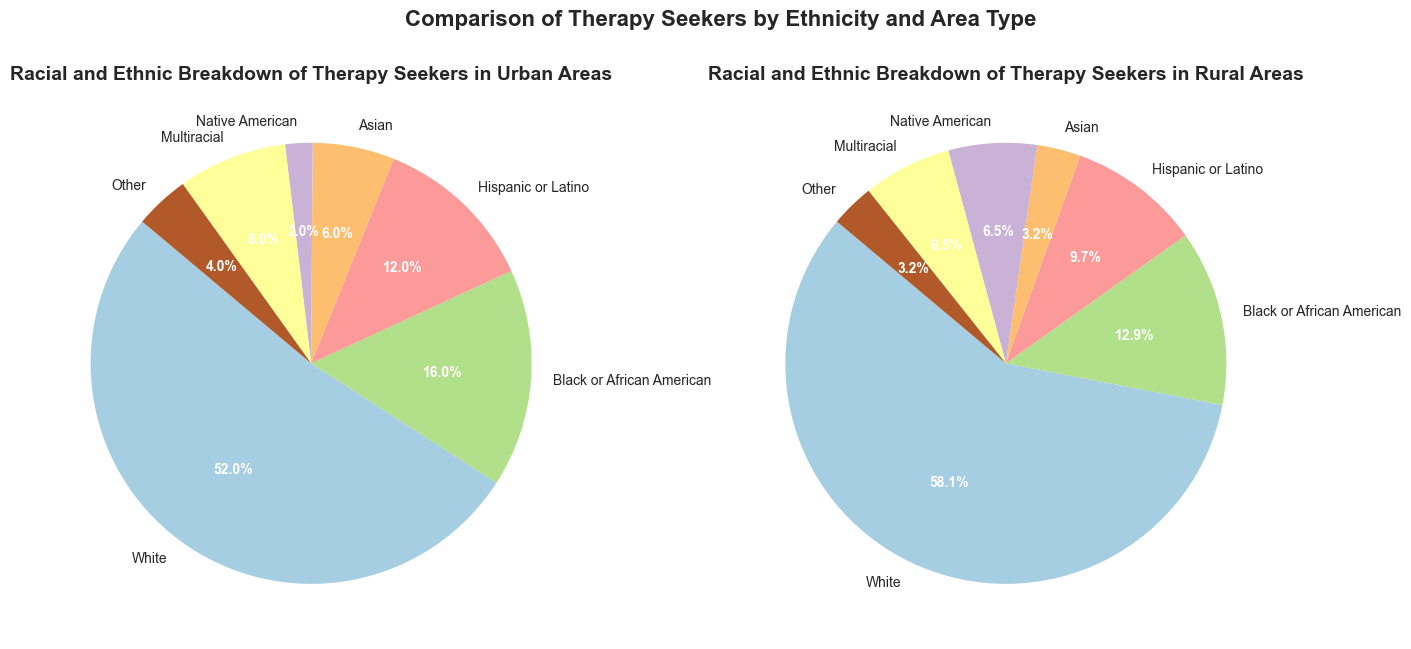Which ethnicity has the highest percentage of therapy seekers in both urban and rural areas? In the urban pie chart, the 'White' segment is the largest, representing 52%. In the rural pie chart, the 'White' segment is also the largest at 60%. Therefore, White has the highest percentage in both areas.
Answer: White Which ethnic group shows the largest difference in therapy seeker percentage between urban and rural areas? To find this, calculate the absolute difference for each ethnicity: White (60 - 52 = 8), Black or African American (16 - 13.3 = 2.7), Hispanic or Latino (12 - 10 = 2), Asian (6 - 3.3 = 2.7), Native American (6.7 - 2 = 4.7), Multiracial (8 - 6.7 = 1.3), Other (4 - 3.3 = 0.7). The largest difference is for the White group.
Answer: White What is the total percentage of minority ethnicities in urban areas? Minority ethnicities include all except White. Summing the values: 16% (Black or African American) + 12% (Hispanic or Latino) + 6% (Asian) + 2% (Native American) + 8% (Multiracial) + 4% (Other) = 48%.
Answer: 48% What is the smallest segment for therapy seekers in urban areas and what percentage does it represent? In the urban pie chart, the 'Native American' segment is the smallest, representing 2%.
Answer: Native American, 2% Comparing the segment sizes, which ethnic group has a higher percentage in rural areas than in urban and what is the difference? Native American therapy seekers are higher in rural areas (6.7%) compared to urban areas (2%). The difference is 6.7% - 2% = 4.7%.
Answer: Native American, 4.7% How does the percentage of Black or African American therapy seekers compare between urban and rural areas? In the urban pie chart, Black or African American is 16%. In the rural pie chart, it is 13.3%. The urban percentage is higher.
Answer: The urban percentage is higher Which ethnic group is represented by the green segment in the urban pie chart? By visually comparing the colors in the pie chart, the green segment for urban areas represents 'Asian' with 6%.
Answer: Asian, 6% What percentage of therapy seekers in rural areas identify as Multiracial? In the rural pie chart, the segment labeled 'Multiracial' shows 6.7%.
Answer: 6.7% If you combine the percentage of Hispanic or Latino therapy seekers in both urban and rural areas, what is the total percentage? Summing the values from both charts, urban (12%) + rural (10%) = 22%.
Answer: 22% Is the percentage of Hispanic or Latino therapy seekers higher in urban or rural areas? In the urban pie chart, Hispanic or Latino is 12%. In the rural pie chart, it is 10%. The urban percentage is higher.
Answer: Urban areas 